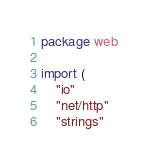Convert code to text. <code><loc_0><loc_0><loc_500><loc_500><_Go_>package web

import (
	"io"
	"net/http"
	"strings"
</code> 